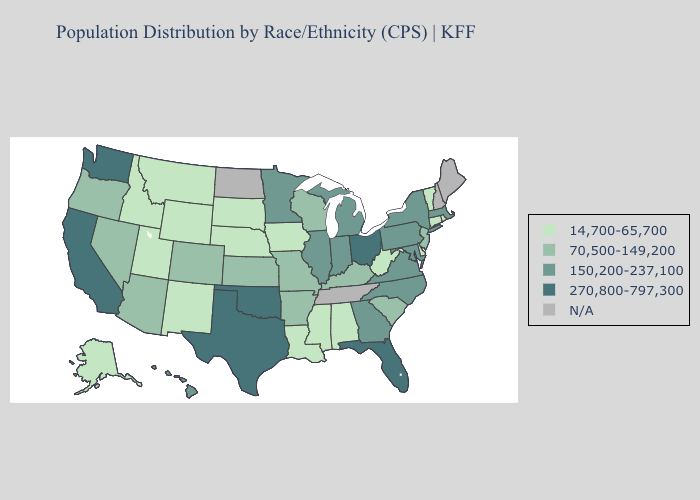Name the states that have a value in the range 150,200-237,100?
Be succinct. Georgia, Hawaii, Illinois, Indiana, Maryland, Massachusetts, Michigan, Minnesota, New York, North Carolina, Pennsylvania, Virginia. Name the states that have a value in the range 270,800-797,300?
Be succinct. California, Florida, Ohio, Oklahoma, Texas, Washington. Does Connecticut have the highest value in the Northeast?
Give a very brief answer. No. Which states have the highest value in the USA?
Short answer required. California, Florida, Ohio, Oklahoma, Texas, Washington. Name the states that have a value in the range 270,800-797,300?
Answer briefly. California, Florida, Ohio, Oklahoma, Texas, Washington. Which states have the highest value in the USA?
Give a very brief answer. California, Florida, Ohio, Oklahoma, Texas, Washington. Does the first symbol in the legend represent the smallest category?
Be succinct. Yes. What is the value of Iowa?
Answer briefly. 14,700-65,700. Name the states that have a value in the range 70,500-149,200?
Concise answer only. Arizona, Arkansas, Colorado, Kansas, Kentucky, Missouri, Nevada, New Jersey, Oregon, South Carolina, Wisconsin. What is the value of Missouri?
Be succinct. 70,500-149,200. Which states have the lowest value in the MidWest?
Answer briefly. Iowa, Nebraska, South Dakota. Does the first symbol in the legend represent the smallest category?
Keep it brief. Yes. Does the map have missing data?
Be succinct. Yes. Which states have the lowest value in the MidWest?
Short answer required. Iowa, Nebraska, South Dakota. What is the lowest value in the USA?
Answer briefly. 14,700-65,700. 